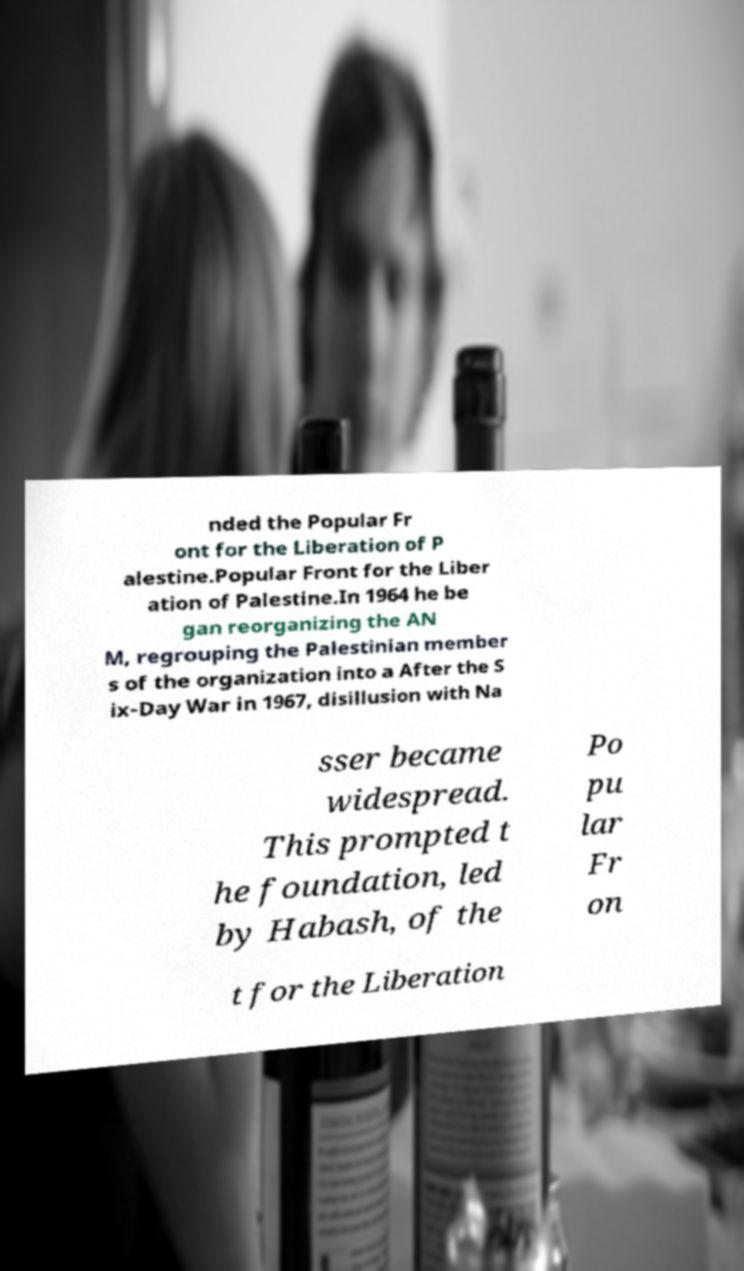There's text embedded in this image that I need extracted. Can you transcribe it verbatim? nded the Popular Fr ont for the Liberation of P alestine.Popular Front for the Liber ation of Palestine.In 1964 he be gan reorganizing the AN M, regrouping the Palestinian member s of the organization into a After the S ix-Day War in 1967, disillusion with Na sser became widespread. This prompted t he foundation, led by Habash, of the Po pu lar Fr on t for the Liberation 